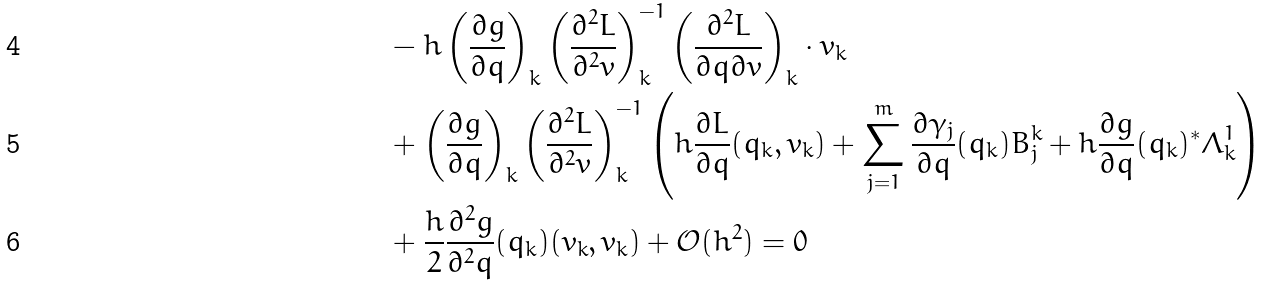Convert formula to latex. <formula><loc_0><loc_0><loc_500><loc_500>& - h \left ( \frac { \partial g } { \partial q } \right ) _ { k } \left ( \frac { \partial ^ { 2 } L } { \partial ^ { 2 } v } \right ) _ { k } ^ { - 1 } \left ( \frac { \partial ^ { 2 } L } { \partial q \partial v } \right ) _ { k } \cdot v _ { k } \\ & + \left ( \frac { \partial g } { \partial q } \right ) _ { k } \left ( \frac { \partial ^ { 2 } L } { \partial ^ { 2 } v } \right ) _ { k } ^ { - 1 } \left ( h \frac { \partial L } { \partial q } ( q _ { k } , v _ { k } ) + \sum _ { j = 1 } ^ { m } \frac { \partial \gamma _ { j } } { \partial q } ( q _ { k } ) B _ { j } ^ { k } + h \frac { \partial g } { \partial q } ( q _ { k } ) ^ { * } \Lambda ^ { 1 } _ { k } \right ) \\ & + \frac { h } { 2 } \frac { \partial ^ { 2 } g } { \partial ^ { 2 } q } ( q _ { k } ) ( v _ { k } , v _ { k } ) + \mathcal { O } ( h ^ { 2 } ) = 0</formula> 